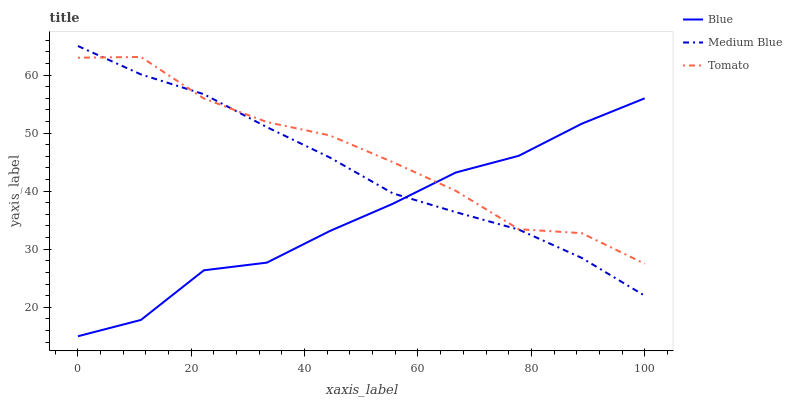Does Blue have the minimum area under the curve?
Answer yes or no. Yes. Does Tomato have the maximum area under the curve?
Answer yes or no. Yes. Does Medium Blue have the minimum area under the curve?
Answer yes or no. No. Does Medium Blue have the maximum area under the curve?
Answer yes or no. No. Is Medium Blue the smoothest?
Answer yes or no. Yes. Is Tomato the roughest?
Answer yes or no. Yes. Is Tomato the smoothest?
Answer yes or no. No. Is Medium Blue the roughest?
Answer yes or no. No. Does Blue have the lowest value?
Answer yes or no. Yes. Does Medium Blue have the lowest value?
Answer yes or no. No. Does Medium Blue have the highest value?
Answer yes or no. Yes. Does Tomato have the highest value?
Answer yes or no. No. Does Tomato intersect Blue?
Answer yes or no. Yes. Is Tomato less than Blue?
Answer yes or no. No. Is Tomato greater than Blue?
Answer yes or no. No. 